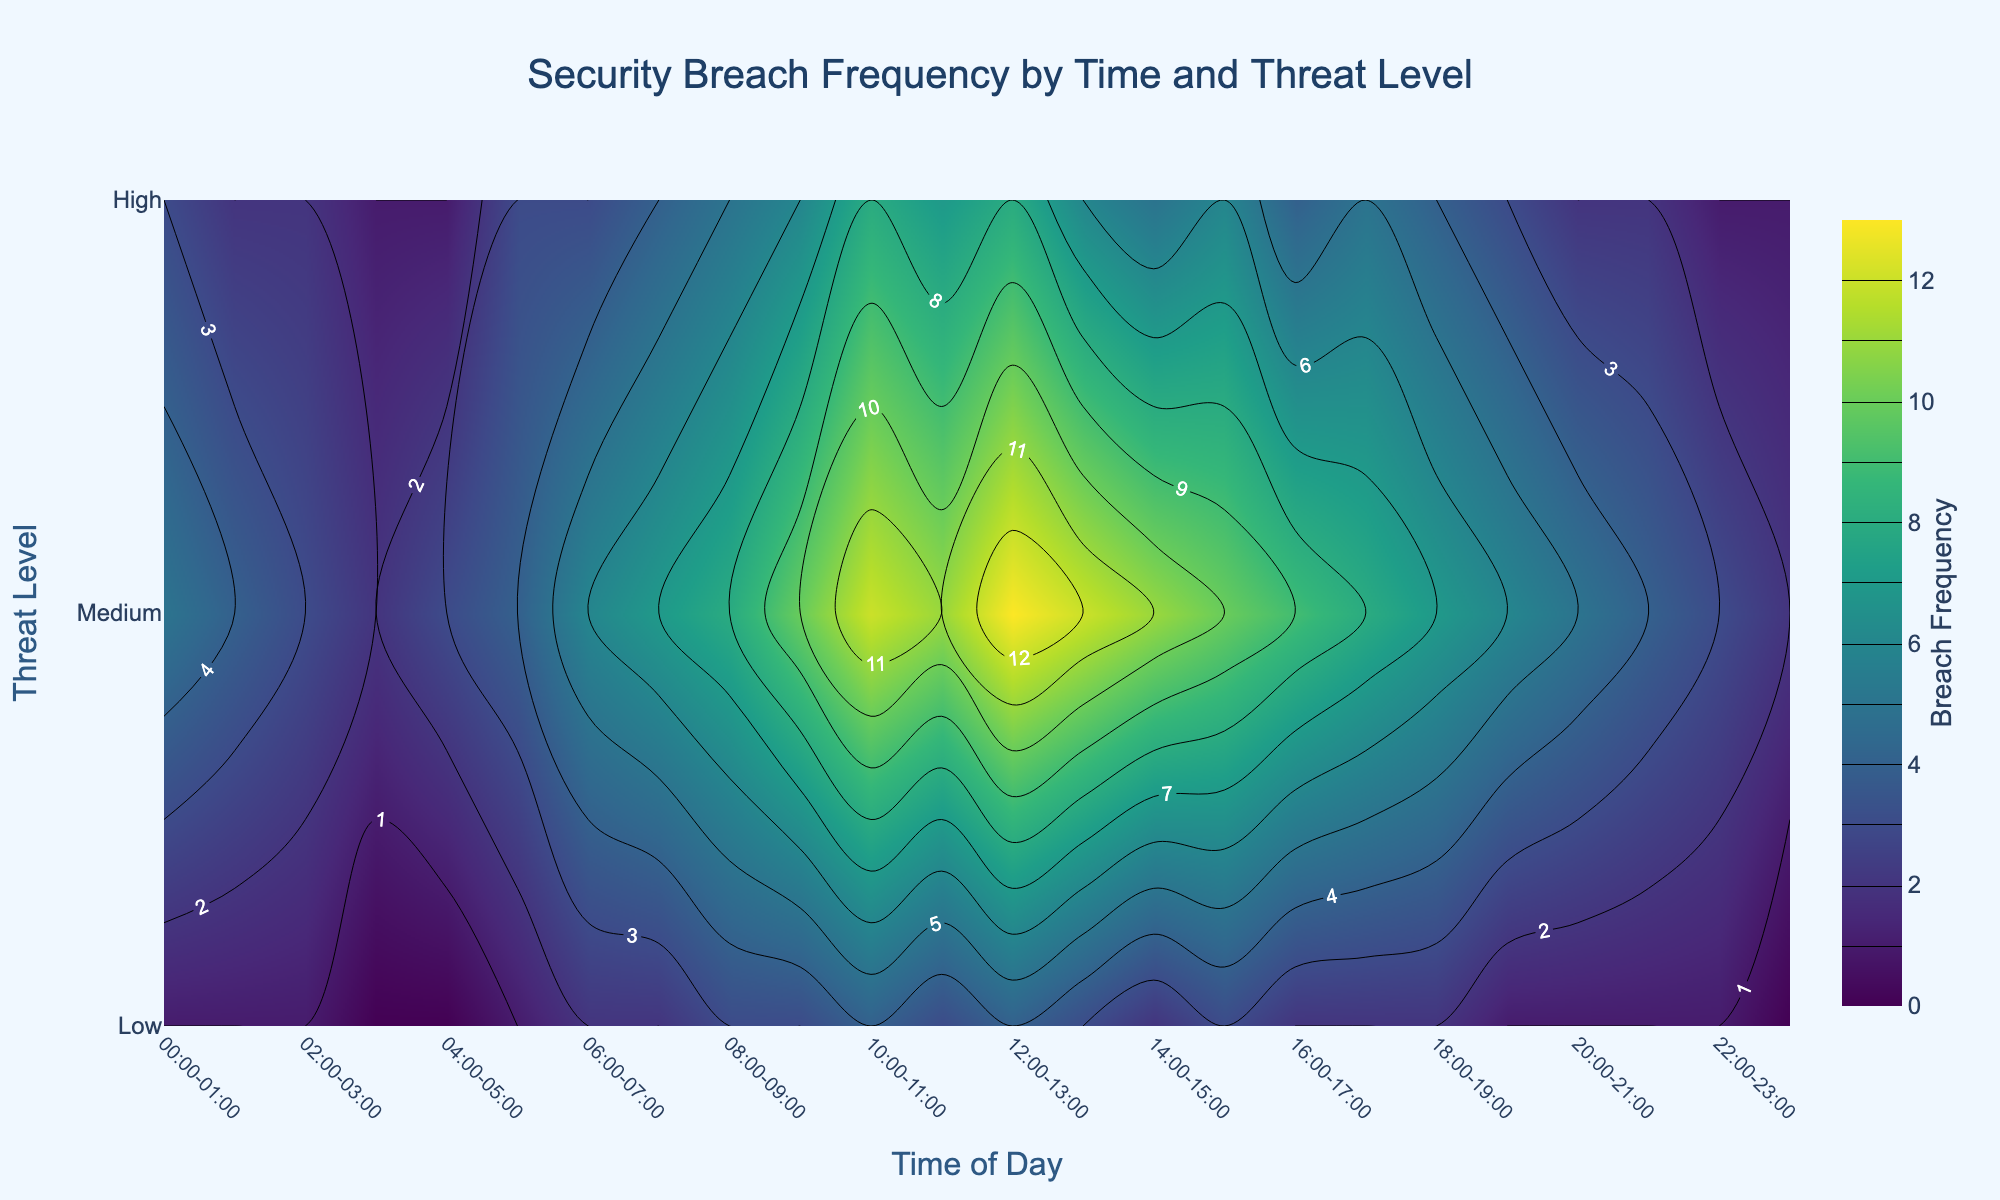What is the title of the figure? The title is displayed at the top of the figure, reading "Security Breach Frequency by Time and Threat Level".
Answer: Security Breach Frequency by Time and Threat Level What are the labels of the x and y axes? The x-axis is labeled "Time of Day", and the y-axis is labeled "Threat Level". These labels are positioned near their respective axes.
Answer: Time of Day and Threat Level What does the colorbar represent? The colorbar on the right side of the figure represents the "Breach Frequency", showing how different colors correspond to different frequencies.
Answer: Breach Frequency Which color scale is used in the plot? The plot uses the "Viridis" color scale, which ranges from dark purple to yellow, typically used to show gradients clearly.
Answer: Viridis What is the plot’s background color? The plot's background color is specified as "#F0F8FF", which is a light blue color.
Answer: Light blue What is the average breach frequency for medium threat level between 08:00 and 12:00? Between 08:00-12:00 for the medium threat level, the breach frequencies are 5, 6, 8, and 7. Summing these values gives 26, and dividing by 4 results in an average frequency of 6.5.
Answer: 6.5 What is the total breach frequency for high threat level across all times of day? Adding up breach frequency values for high threat level at all times gives (1 + 1 + 1 + 0 + 0 + 1 + 2 + 2 + 3 + 3 + 4 + 3 + 4 + 3 + 2 + 3 + 2 + 2 + 2 + 1 + 1 + 1) = 40.
Answer: 40 What's the difference in breach frequency between low and high threat levels at 10:00-11:00? At 10:00-11:00, the breach frequency for low is 12 and for high is 4. The difference is 12 - 4 = 8.
Answer: 8 During which time period is the breach frequency highest for high threat level? To determine the highest breach frequency for high threat level, look for the peak value in the high threat level row, which occurs at 4 for 10:00-11:00 and 12:00-13:00.
Answer: 10:00-11:00 and 12:00-13:00 Which time period has a higher breach frequency for medium threat level: 04:00-05:00 or 18:00-19:00? Comparing the breach frequencies at 04:00-05:00 (1) and 18:00-19:00 (4) for medium threat level shows 18:00-19:00 is higher.
Answer: 18:00-19:00 At what time does the low threat level breach frequency peak? The peak for low threat level can be seen at the highest contour level corresponding to 12:00-13:00, with a frequency of 13.
Answer: 12:00-13:00 What pattern do you observe in breach frequencies for low threat levels throughout the day? The breach frequency for low threat levels generally increases through the morning, peaks around noon, and then decreases towards the evening. This is visible as a gradient on the contour plot.
Answer: Increase in morning, peak around noon, decrease in evening Is there a time of day when all threat levels have zero breaches? No section of the contour plot shows a zero breach frequency for all corresponding threat levels at any given time.
Answer: No Which threat level consistently has the lowest breach frequency and why? The high threat level consistently has the lowest breach frequency, identifiable by the darker or less intense colors representing lower frequencies in its contour band.
Answer: High threat level 